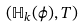Convert formula to latex. <formula><loc_0><loc_0><loc_500><loc_500>( \mathbb { H } _ { k } ( \phi ) , T )</formula> 